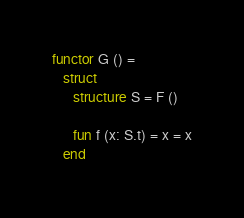Convert code to text. <code><loc_0><loc_0><loc_500><loc_500><_SML_>
functor G () =
   struct
      structure S = F ()

      fun f (x: S.t) = x = x
   end
</code> 